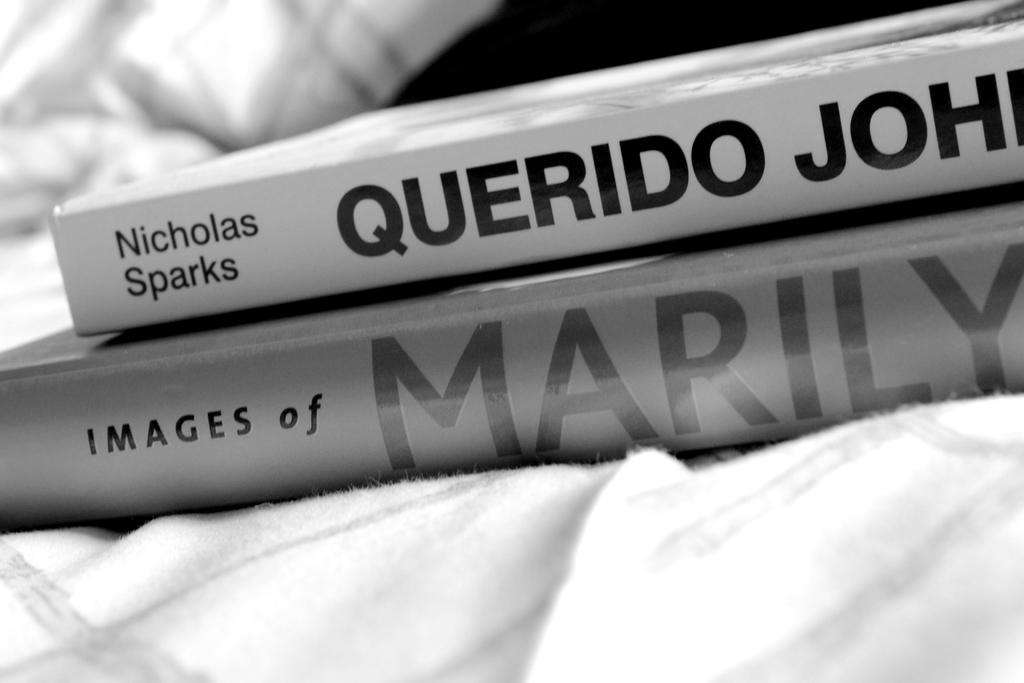<image>
Share a concise interpretation of the image provided. A book "Querido John" by Nicholas Sparks sits on top of another book "Images of Marilyn." 